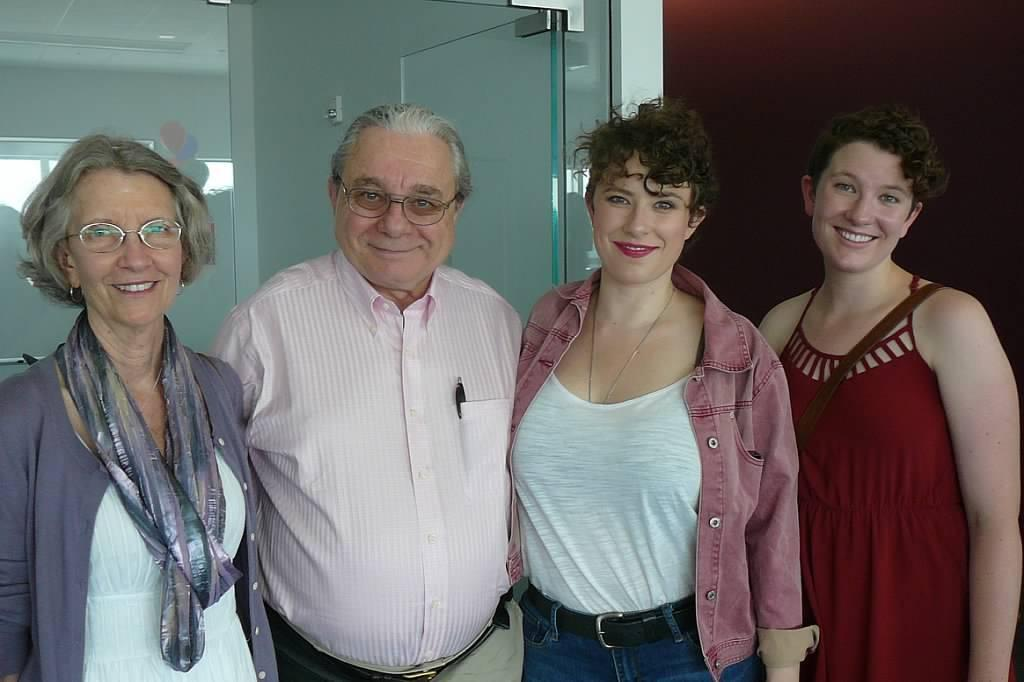How many people are in the image? There are three women and a man in the image, making a total of four people. What are the people in the image doing? The people are standing and laughing. What can be seen in the background of the image? There is a glass wall in the background of the image. What type of kite is the man holding in the image? There is no kite present in the image; the people are standing and laughing without any visible objects in their hands. 